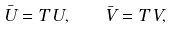<formula> <loc_0><loc_0><loc_500><loc_500>\bar { U } = T \, U , \quad \bar { V } = T \, V ,</formula> 